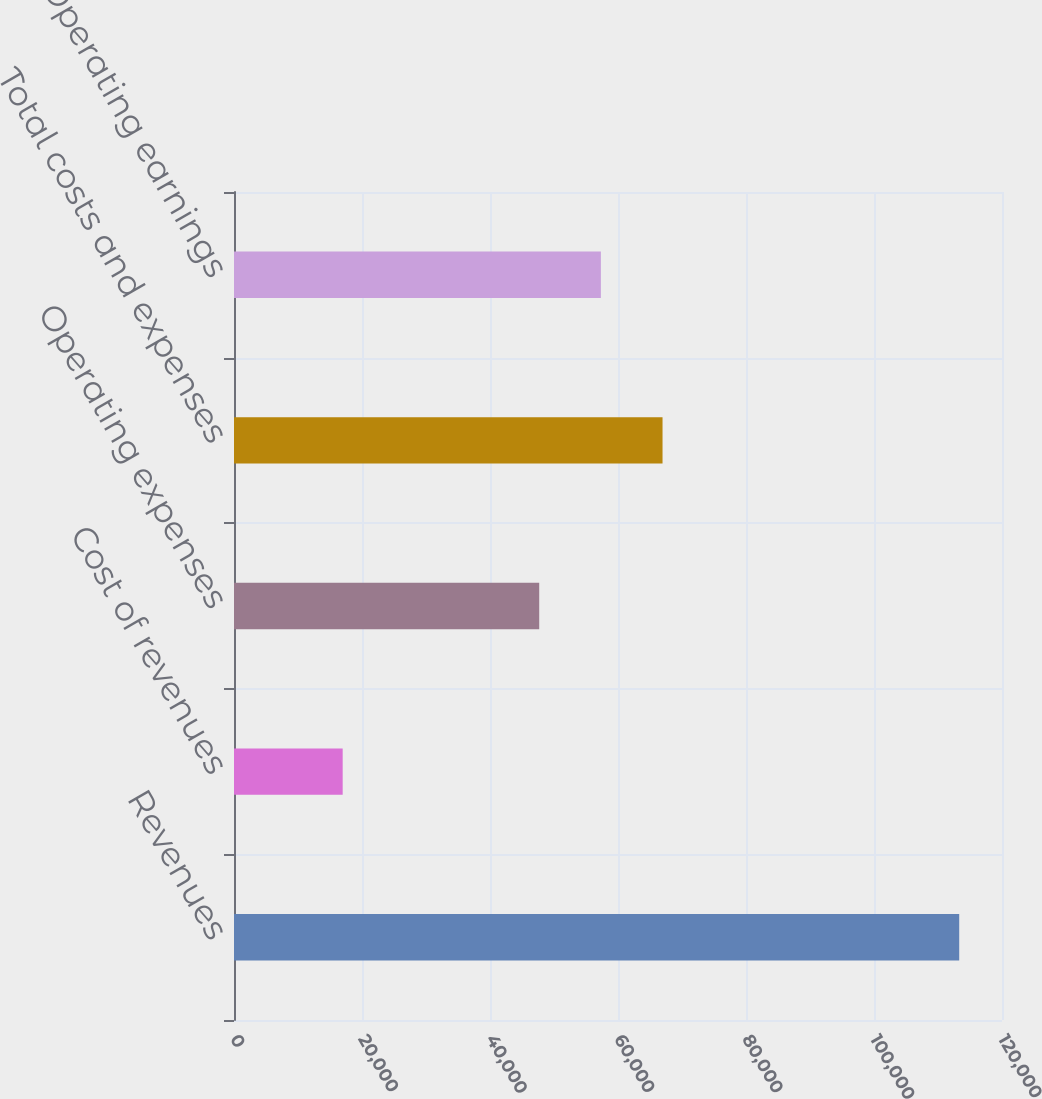<chart> <loc_0><loc_0><loc_500><loc_500><bar_chart><fcel>Revenues<fcel>Cost of revenues<fcel>Operating expenses<fcel>Total costs and expenses<fcel>Operating earnings<nl><fcel>113314<fcel>16981<fcel>47691<fcel>66957.6<fcel>57324.3<nl></chart> 